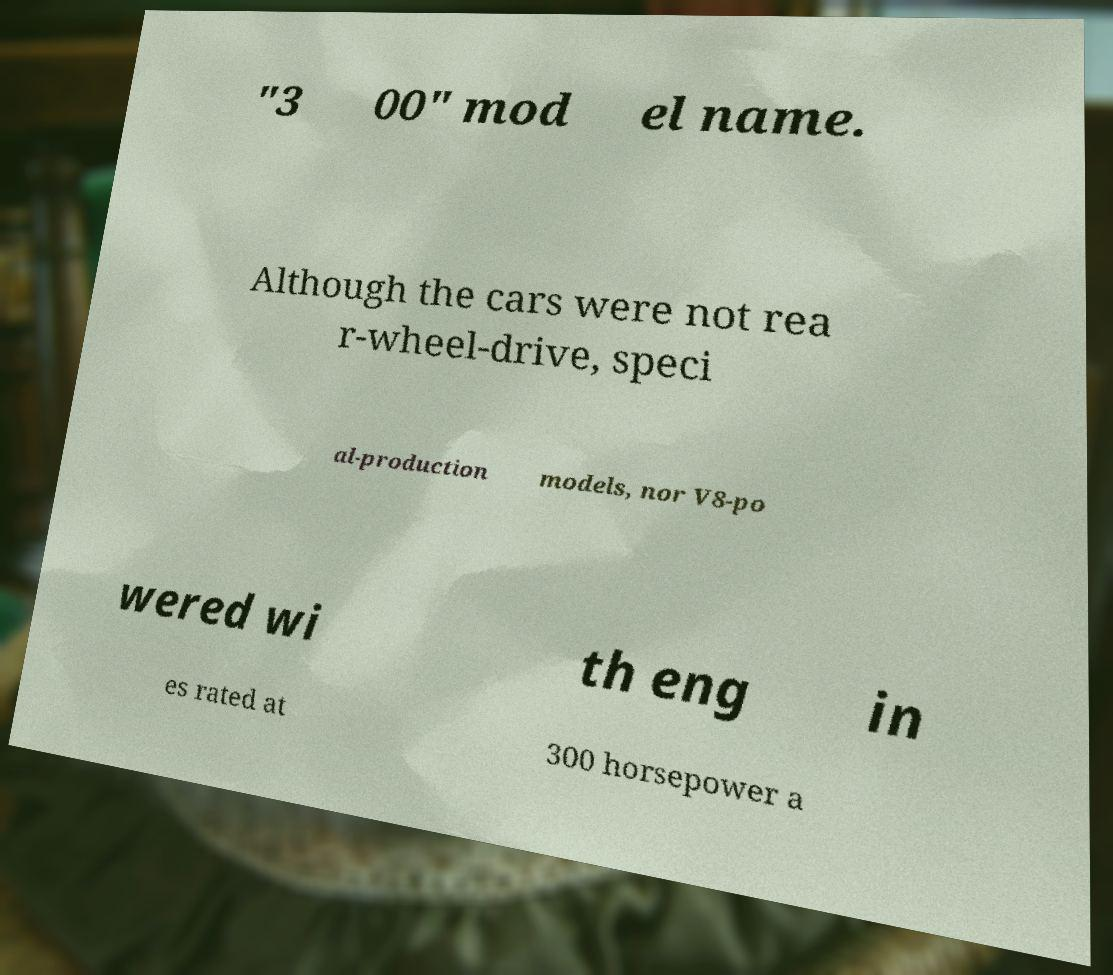What messages or text are displayed in this image? I need them in a readable, typed format. "3 00" mod el name. Although the cars were not rea r-wheel-drive, speci al-production models, nor V8-po wered wi th eng in es rated at 300 horsepower a 